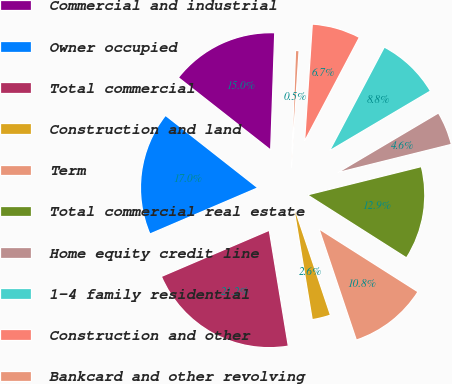<chart> <loc_0><loc_0><loc_500><loc_500><pie_chart><fcel>Commercial and industrial<fcel>Owner occupied<fcel>Total commercial<fcel>Construction and land<fcel>Term<fcel>Total commercial real estate<fcel>Home equity credit line<fcel>1-4 family residential<fcel>Construction and other<fcel>Bankcard and other revolving<nl><fcel>14.96%<fcel>17.03%<fcel>21.16%<fcel>2.56%<fcel>10.83%<fcel>12.89%<fcel>4.63%<fcel>8.76%<fcel>6.69%<fcel>0.49%<nl></chart> 